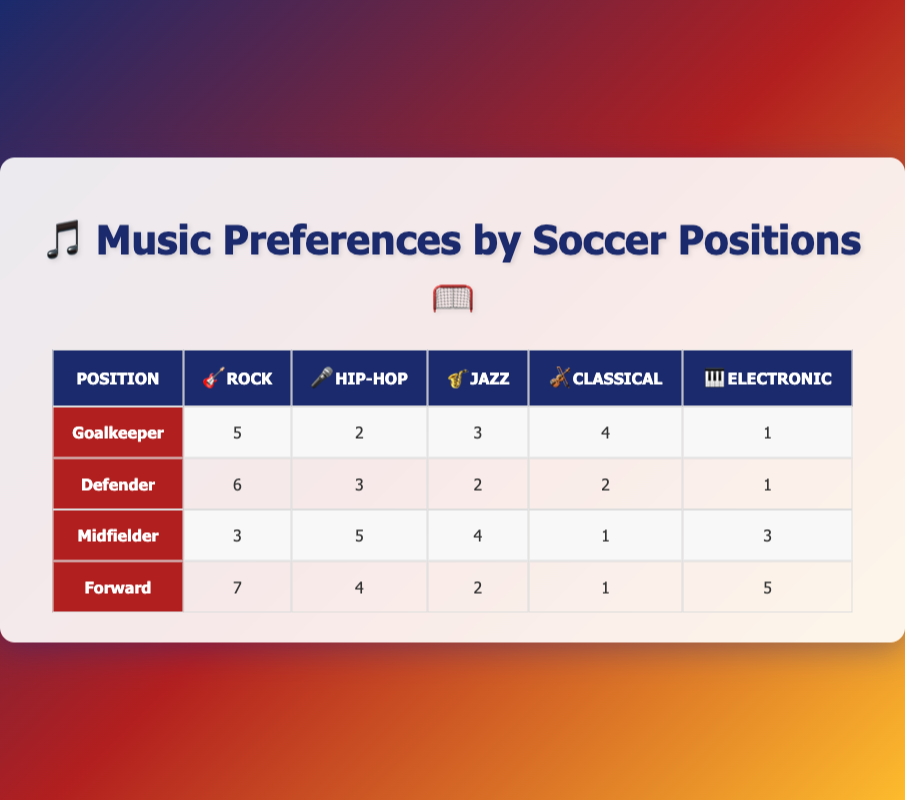How many soccer players preferred Rock music as their favorite genre? To find this, I will sum up the values for the 'Rock' column from all positions: 5 (Goalkeeper) + 6 (Defender) + 3 (Midfielder) + 7 (Forward) = 21
Answer: 21 Which soccer position has the highest preference for Electronic music? Looking at the 'Electronic' column, the values are 1 (Goalkeeper), 1 (Defender), 3 (Midfielder), and 5 (Forward). The highest value is 5 for the Forward position.
Answer: Forward What is the total number of players who prefer Jazz music? To calculate this, I will sum the values in the 'Jazz' column: 3 (Goalkeeper) + 2 (Defender) + 4 (Midfielder) + 2 (Forward) = 11
Answer: 11 Do more midfielders prefer Hip-Hop than defenders? The preference for Hip-Hop is 5 for Midfielders and 3 for Defenders. Since 5 is greater than 3, the statement is true.
Answer: Yes What is the average preference score for Classical music across all positions? To find the average, I will sum the values from the 'Classical' column: 4 (Goalkeeper) + 2 (Defender) + 1 (Midfielder) + 1 (Forward) = 8. Then, divide by the number of positions (4), so 8/4 = 2.
Answer: 2 